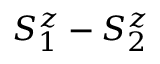<formula> <loc_0><loc_0><loc_500><loc_500>S _ { 1 } ^ { z } - S _ { 2 } ^ { z }</formula> 